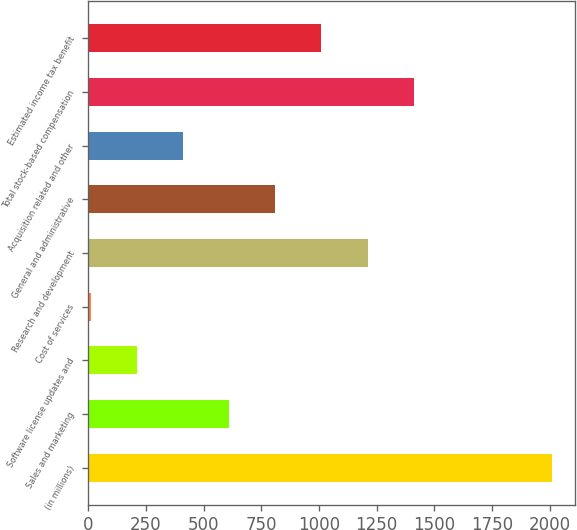Convert chart. <chart><loc_0><loc_0><loc_500><loc_500><bar_chart><fcel>(in millions)<fcel>Sales and marketing<fcel>Software license updates and<fcel>Cost of services<fcel>Research and development<fcel>General and administrative<fcel>Acquisition related and other<fcel>Total stock-based compensation<fcel>Estimated income tax benefit<nl><fcel>2009<fcel>611.1<fcel>211.7<fcel>12<fcel>1210.2<fcel>810.8<fcel>411.4<fcel>1409.9<fcel>1010.5<nl></chart> 